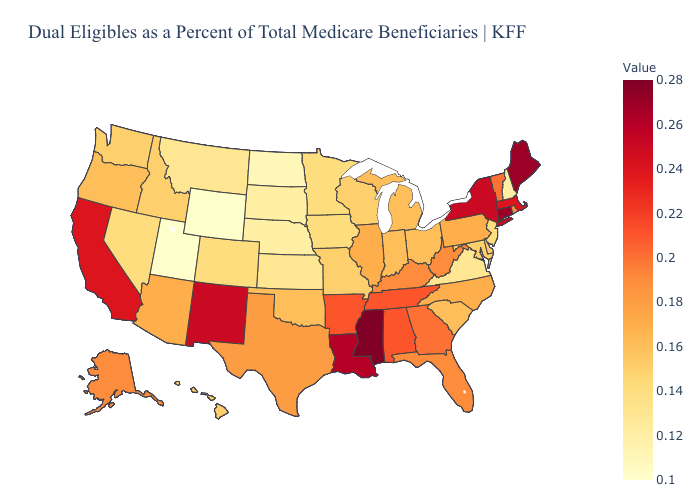Among the states that border Mississippi , does Louisiana have the lowest value?
Short answer required. No. Does Arizona have the lowest value in the West?
Be succinct. No. Does the map have missing data?
Be succinct. No. Among the states that border North Carolina , which have the lowest value?
Quick response, please. Virginia. Which states have the lowest value in the USA?
Short answer required. Utah, Wyoming. Does North Dakota have the lowest value in the MidWest?
Answer briefly. Yes. Among the states that border Mississippi , which have the highest value?
Be succinct. Louisiana. 